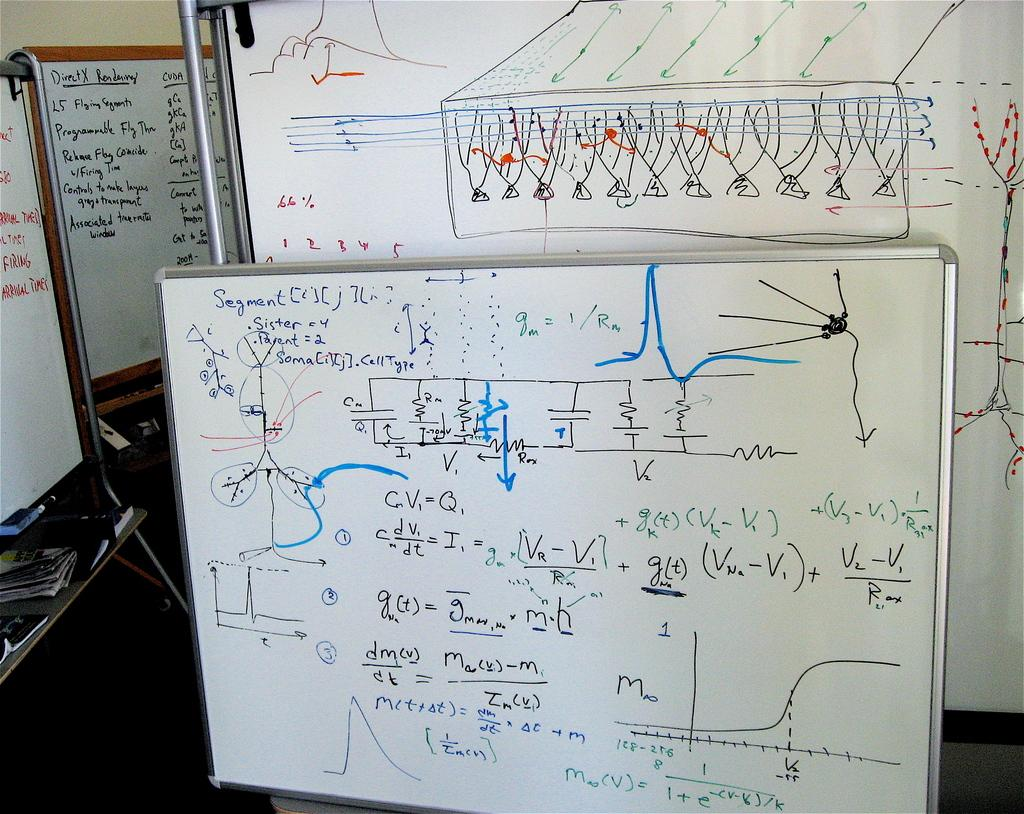<image>
Render a clear and concise summary of the photo. Several white boards showing different graphs and math problems with segment formula information. 